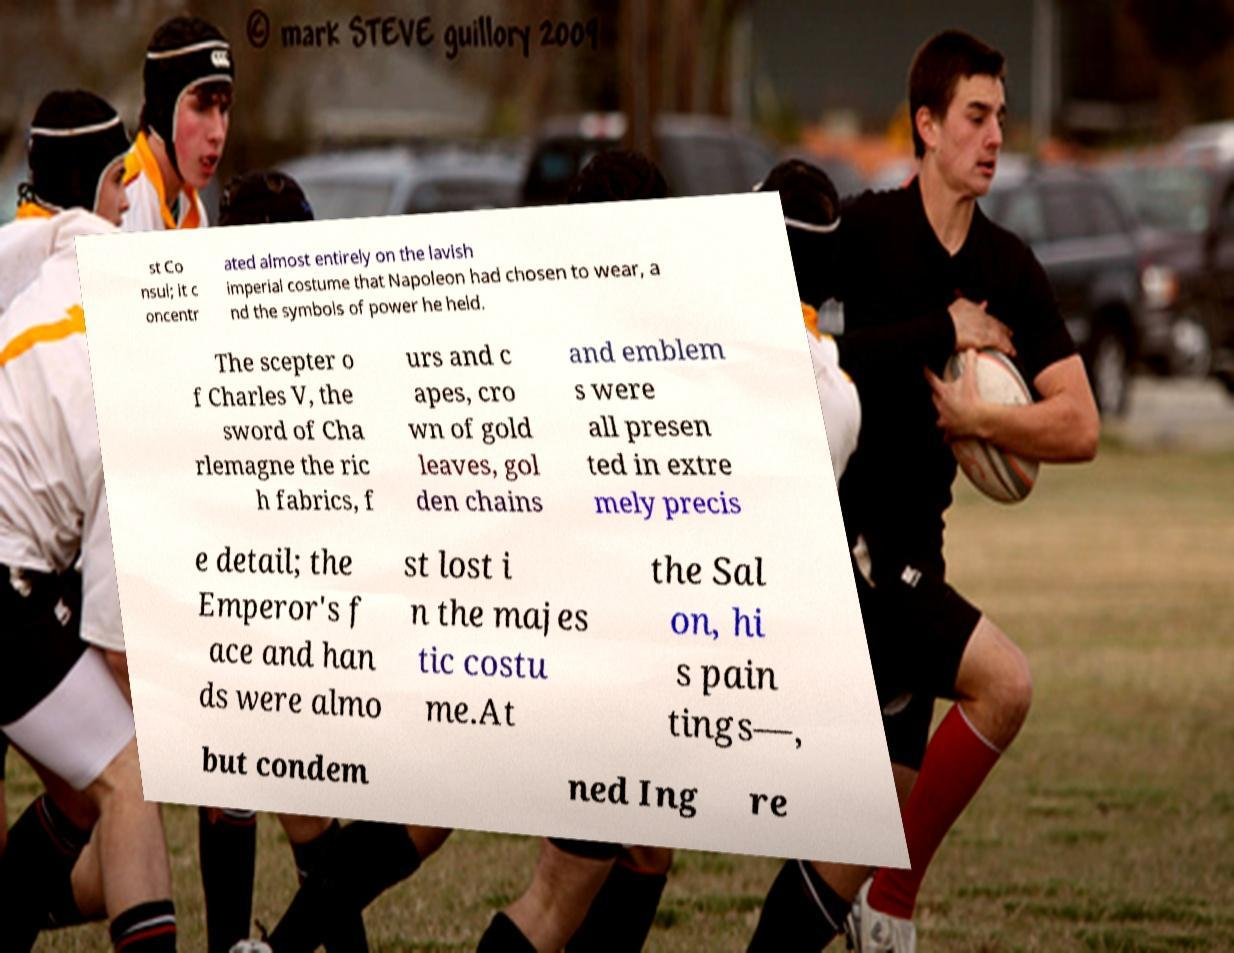Can you read and provide the text displayed in the image?This photo seems to have some interesting text. Can you extract and type it out for me? st Co nsul; it c oncentr ated almost entirely on the lavish imperial costume that Napoleon had chosen to wear, a nd the symbols of power he held. The scepter o f Charles V, the sword of Cha rlemagne the ric h fabrics, f urs and c apes, cro wn of gold leaves, gol den chains and emblem s were all presen ted in extre mely precis e detail; the Emperor's f ace and han ds were almo st lost i n the majes tic costu me.At the Sal on, hi s pain tings—, but condem ned Ing re 